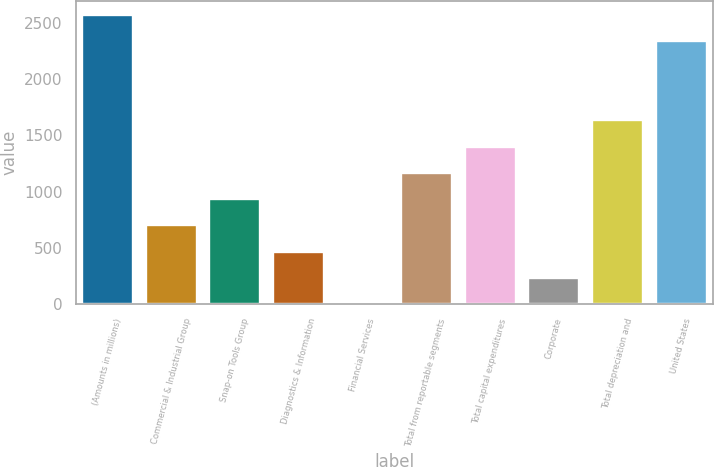Convert chart. <chart><loc_0><loc_0><loc_500><loc_500><bar_chart><fcel>(Amounts in millions)<fcel>Commercial & Industrial Group<fcel>Snap-on Tools Group<fcel>Diagnostics & Information<fcel>Financial Services<fcel>Total from reportable segments<fcel>Total capital expenditures<fcel>Corporate<fcel>Total depreciation and<fcel>United States<nl><fcel>2567.95<fcel>701.15<fcel>934.5<fcel>467.8<fcel>1.1<fcel>1167.85<fcel>1401.2<fcel>234.45<fcel>1634.55<fcel>2334.6<nl></chart> 